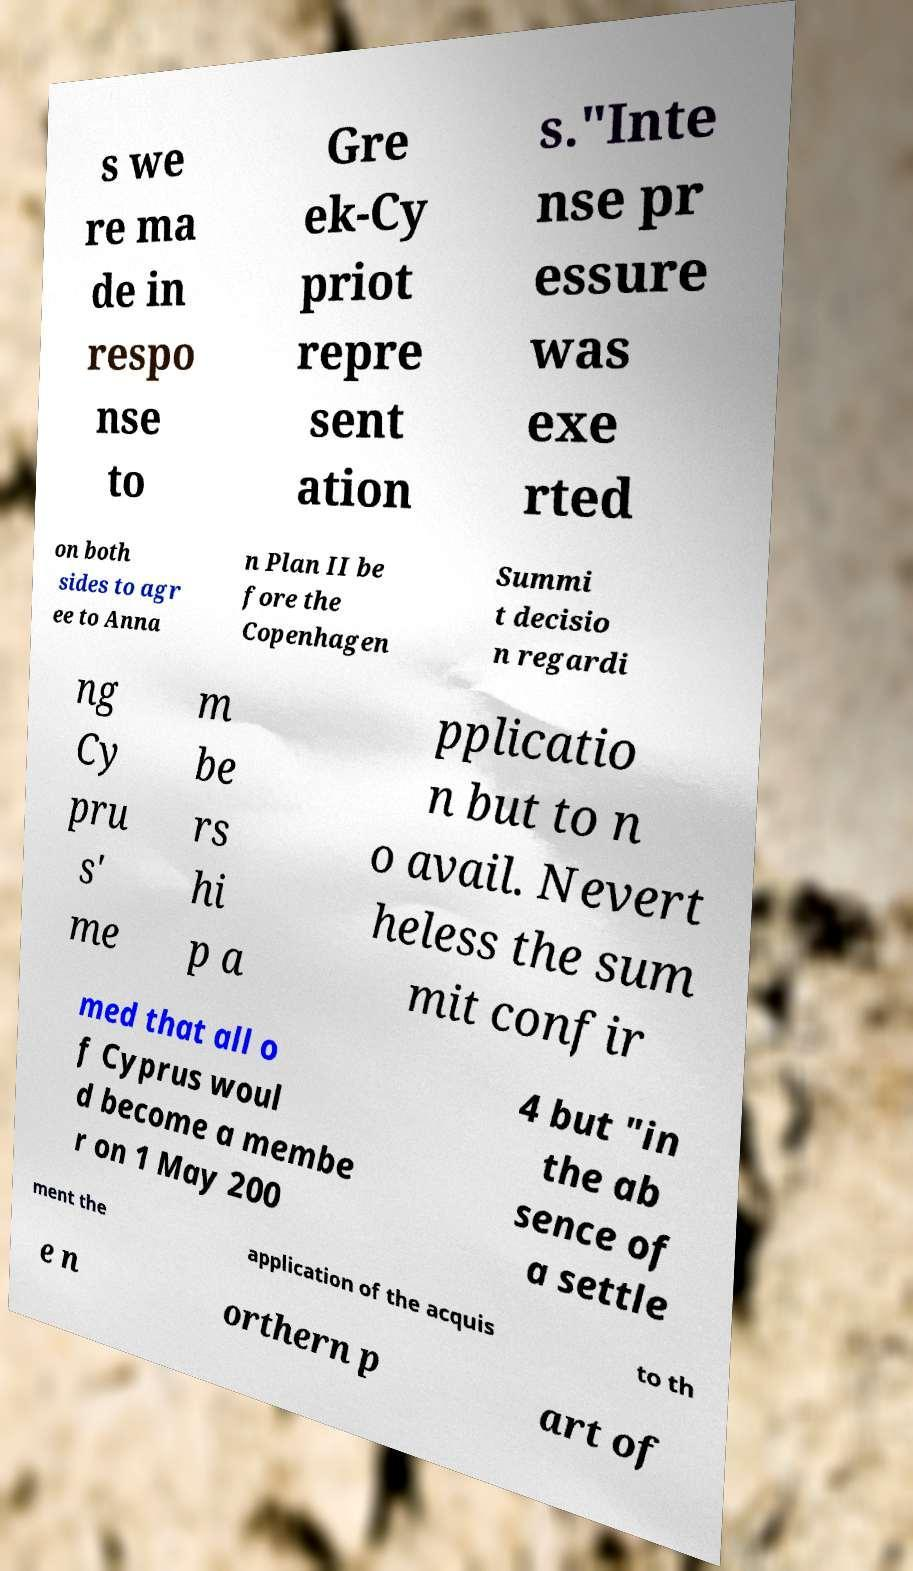Please identify and transcribe the text found in this image. s we re ma de in respo nse to Gre ek-Cy priot repre sent ation s."Inte nse pr essure was exe rted on both sides to agr ee to Anna n Plan II be fore the Copenhagen Summi t decisio n regardi ng Cy pru s' me m be rs hi p a pplicatio n but to n o avail. Nevert heless the sum mit confir med that all o f Cyprus woul d become a membe r on 1 May 200 4 but "in the ab sence of a settle ment the application of the acquis to th e n orthern p art of 